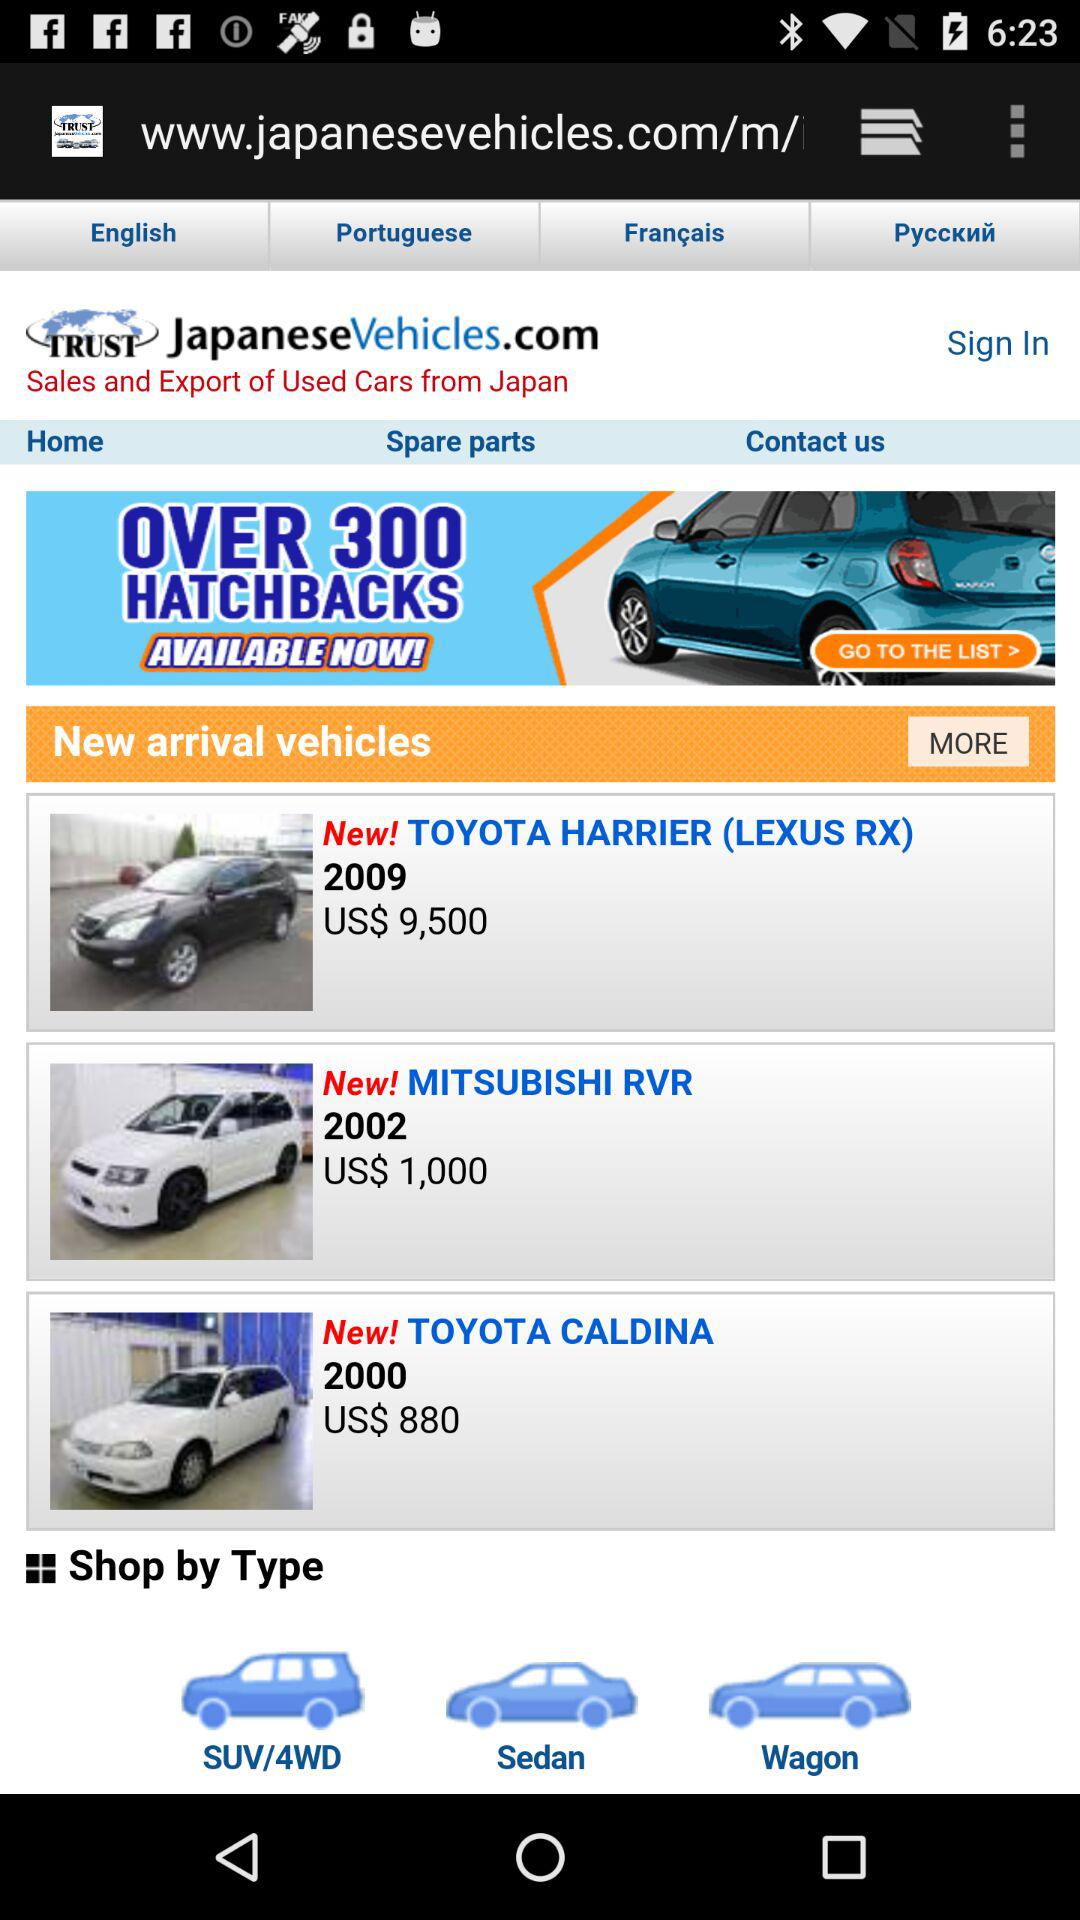How many vehicles are there in the new arrival section?
Answer the question using a single word or phrase. 3 